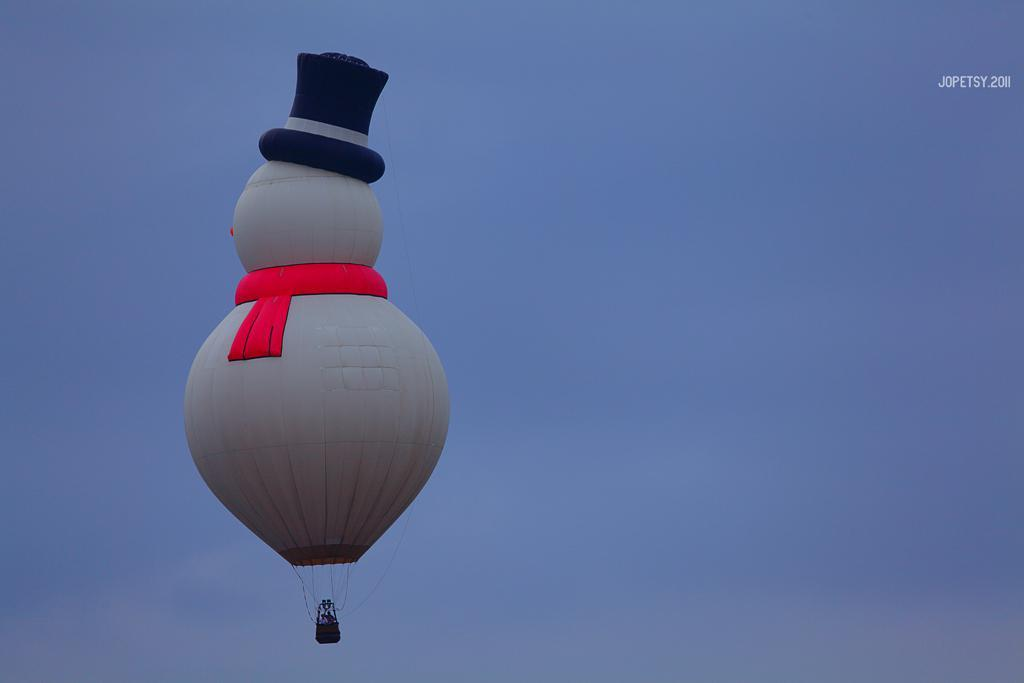What is the main object in the image? There is a parachute in the image. What colors are present on the parachute? The parachute has white, red, and black colors. Are there any people in the parachute? Yes, there are persons in the parachute. What can be seen in the background of the image? The background of the image is the sky. What is the color of the sky in the image? The sky is blue in color. Where is the tray located in the image? There is no tray present in the image. Is the queen sitting on the parachute in the image? There is no queen present in the image; it features a parachute with persons inside. 